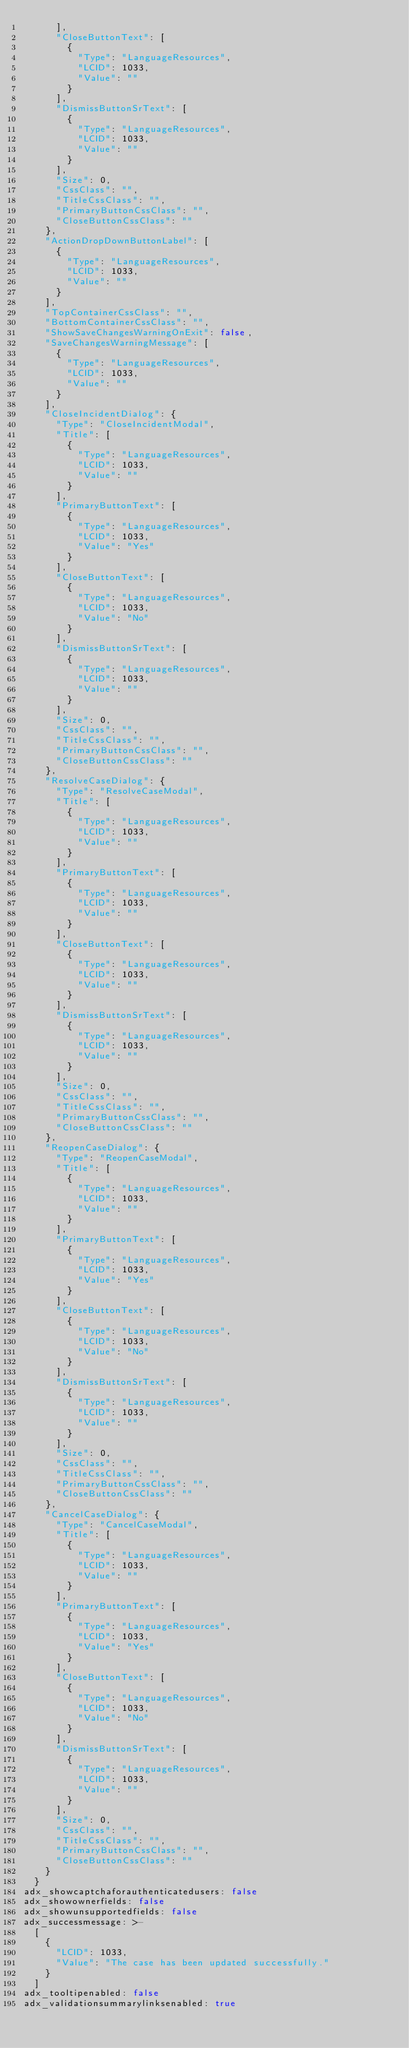<code> <loc_0><loc_0><loc_500><loc_500><_YAML_>      ],
      "CloseButtonText": [
        {
          "Type": "LanguageResources",
          "LCID": 1033,
          "Value": ""
        }
      ],
      "DismissButtonSrText": [
        {
          "Type": "LanguageResources",
          "LCID": 1033,
          "Value": ""
        }
      ],
      "Size": 0,
      "CssClass": "",
      "TitleCssClass": "",
      "PrimaryButtonCssClass": "",
      "CloseButtonCssClass": ""
    },
    "ActionDropDownButtonLabel": [
      {
        "Type": "LanguageResources",
        "LCID": 1033,
        "Value": ""
      }
    ],
    "TopContainerCssClass": "",
    "BottomContainerCssClass": "",
    "ShowSaveChangesWarningOnExit": false,
    "SaveChangesWarningMessage": [
      {
        "Type": "LanguageResources",
        "LCID": 1033,
        "Value": ""
      }
    ],
    "CloseIncidentDialog": {
      "Type": "CloseIncidentModal",
      "Title": [
        {
          "Type": "LanguageResources",
          "LCID": 1033,
          "Value": ""
        }
      ],
      "PrimaryButtonText": [
        {
          "Type": "LanguageResources",
          "LCID": 1033,
          "Value": "Yes"
        }
      ],
      "CloseButtonText": [
        {
          "Type": "LanguageResources",
          "LCID": 1033,
          "Value": "No"
        }
      ],
      "DismissButtonSrText": [
        {
          "Type": "LanguageResources",
          "LCID": 1033,
          "Value": ""
        }
      ],
      "Size": 0,
      "CssClass": "",
      "TitleCssClass": "",
      "PrimaryButtonCssClass": "",
      "CloseButtonCssClass": ""
    },
    "ResolveCaseDialog": {
      "Type": "ResolveCaseModal",
      "Title": [
        {
          "Type": "LanguageResources",
          "LCID": 1033,
          "Value": ""
        }
      ],
      "PrimaryButtonText": [
        {
          "Type": "LanguageResources",
          "LCID": 1033,
          "Value": ""
        }
      ],
      "CloseButtonText": [
        {
          "Type": "LanguageResources",
          "LCID": 1033,
          "Value": ""
        }
      ],
      "DismissButtonSrText": [
        {
          "Type": "LanguageResources",
          "LCID": 1033,
          "Value": ""
        }
      ],
      "Size": 0,
      "CssClass": "",
      "TitleCssClass": "",
      "PrimaryButtonCssClass": "",
      "CloseButtonCssClass": ""
    },
    "ReopenCaseDialog": {
      "Type": "ReopenCaseModal",
      "Title": [
        {
          "Type": "LanguageResources",
          "LCID": 1033,
          "Value": ""
        }
      ],
      "PrimaryButtonText": [
        {
          "Type": "LanguageResources",
          "LCID": 1033,
          "Value": "Yes"
        }
      ],
      "CloseButtonText": [
        {
          "Type": "LanguageResources",
          "LCID": 1033,
          "Value": "No"
        }
      ],
      "DismissButtonSrText": [
        {
          "Type": "LanguageResources",
          "LCID": 1033,
          "Value": ""
        }
      ],
      "Size": 0,
      "CssClass": "",
      "TitleCssClass": "",
      "PrimaryButtonCssClass": "",
      "CloseButtonCssClass": ""
    },
    "CancelCaseDialog": {
      "Type": "CancelCaseModal",
      "Title": [
        {
          "Type": "LanguageResources",
          "LCID": 1033,
          "Value": ""
        }
      ],
      "PrimaryButtonText": [
        {
          "Type": "LanguageResources",
          "LCID": 1033,
          "Value": "Yes"
        }
      ],
      "CloseButtonText": [
        {
          "Type": "LanguageResources",
          "LCID": 1033,
          "Value": "No"
        }
      ],
      "DismissButtonSrText": [
        {
          "Type": "LanguageResources",
          "LCID": 1033,
          "Value": ""
        }
      ],
      "Size": 0,
      "CssClass": "",
      "TitleCssClass": "",
      "PrimaryButtonCssClass": "",
      "CloseButtonCssClass": ""
    }
  }
adx_showcaptchaforauthenticatedusers: false
adx_showownerfields: false
adx_showunsupportedfields: false
adx_successmessage: >-
  [
    {
      "LCID": 1033,
      "Value": "The case has been updated successfully."
    }
  ]
adx_tooltipenabled: false
adx_validationsummarylinksenabled: true
</code> 